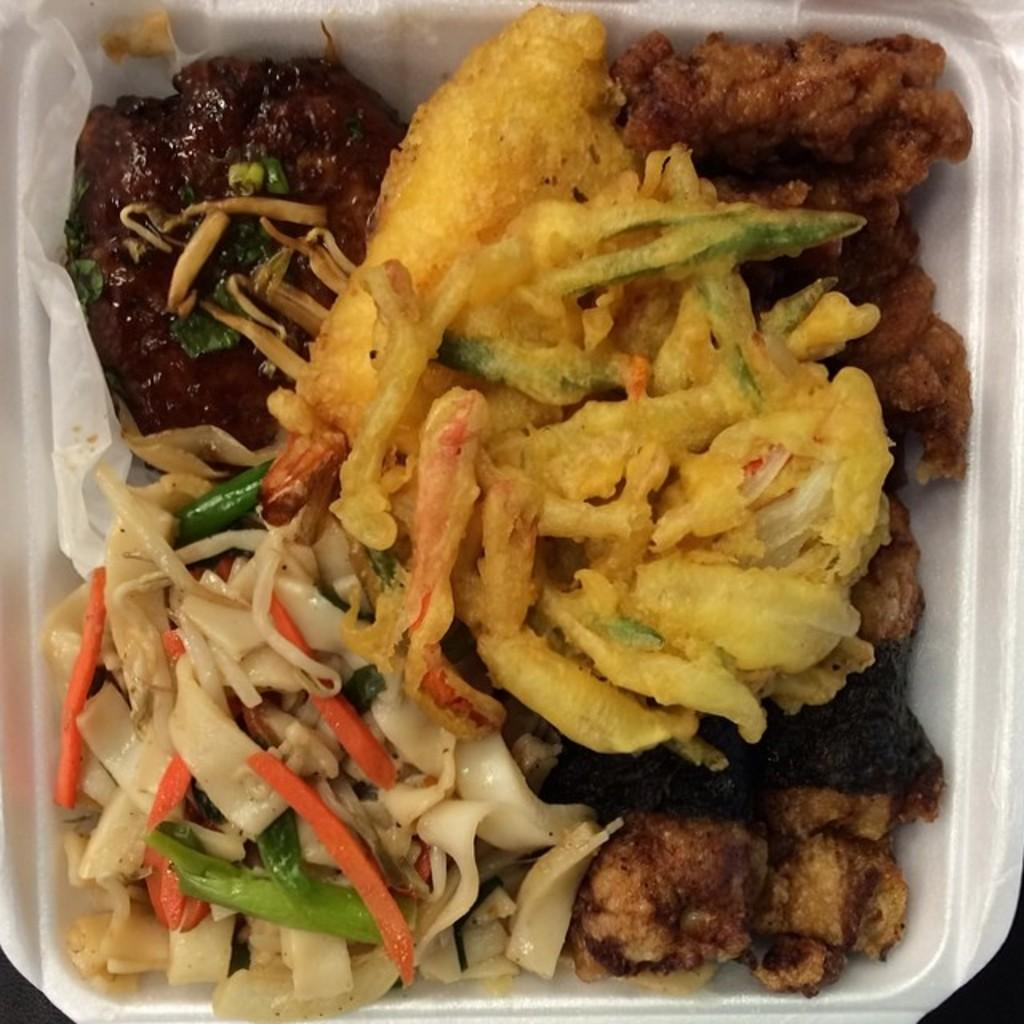What shape is the bowl in the image? The bowl in the image is square-shaped. What types of food are in the bowl? The bowl contains vegetable slices, fries, and some curries. What type of lettuce is being sold at the shop in the image? There is: There is no shop or lettuce present in the image. 